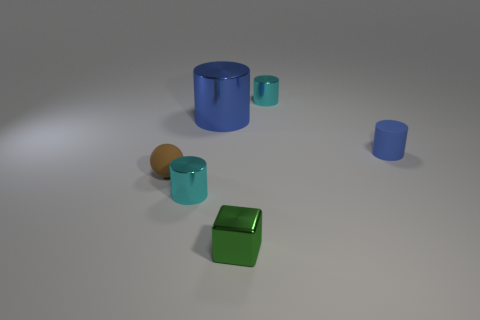Add 2 small green objects. How many objects exist? 8 Subtract all cubes. How many objects are left? 5 Subtract 0 blue blocks. How many objects are left? 6 Subtract all small purple cylinders. Subtract all metallic cylinders. How many objects are left? 3 Add 5 small cylinders. How many small cylinders are left? 8 Add 4 purple matte objects. How many purple matte objects exist? 4 